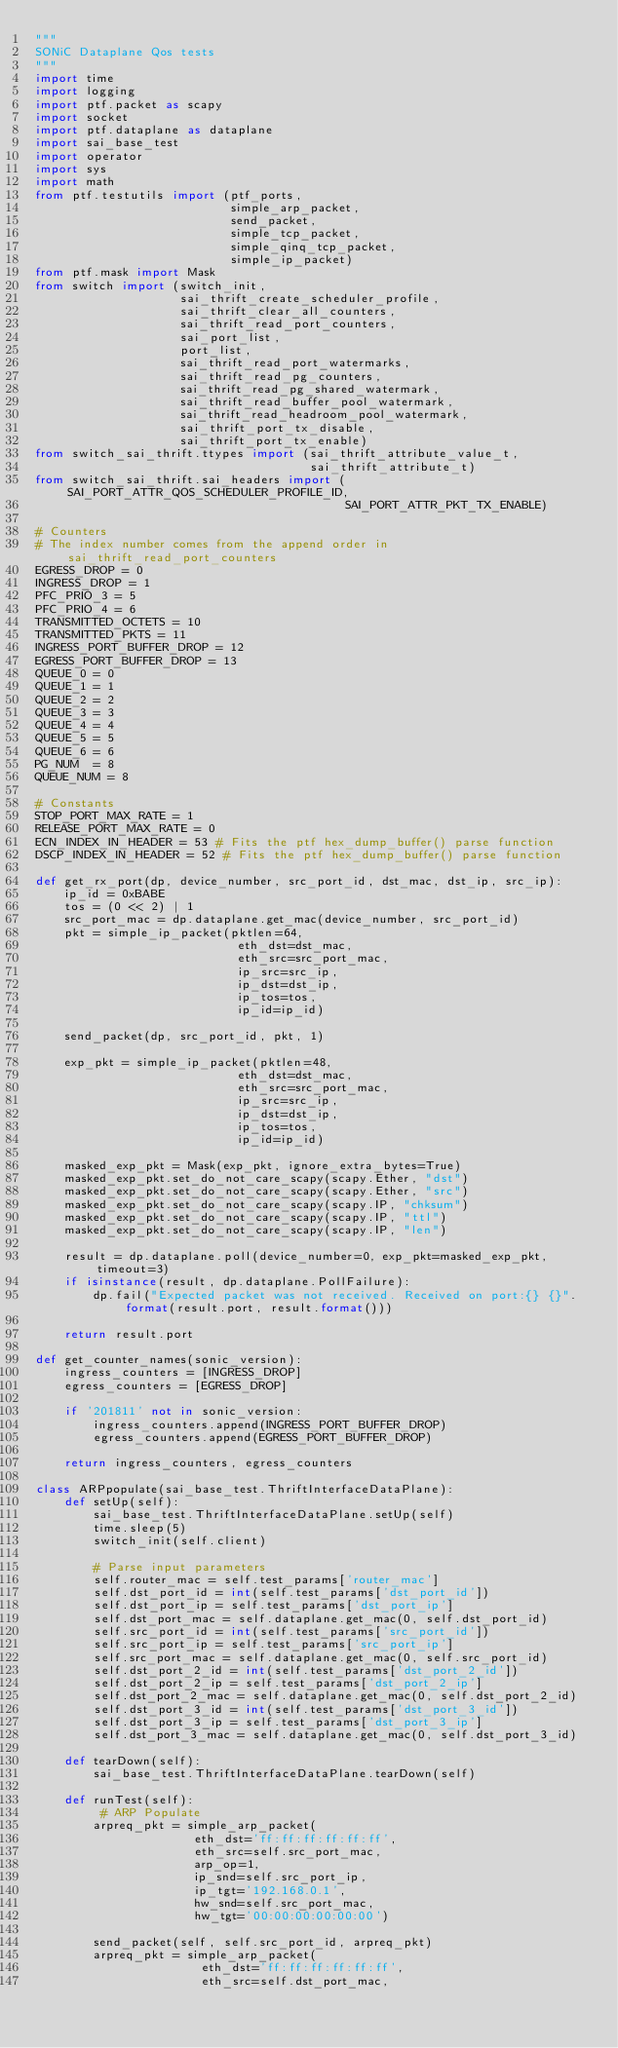Convert code to text. <code><loc_0><loc_0><loc_500><loc_500><_Python_>"""
SONiC Dataplane Qos tests
"""
import time
import logging
import ptf.packet as scapy
import socket
import ptf.dataplane as dataplane
import sai_base_test
import operator
import sys
import math
from ptf.testutils import (ptf_ports,
                           simple_arp_packet,
                           send_packet,
                           simple_tcp_packet,
                           simple_qinq_tcp_packet,
                           simple_ip_packet)
from ptf.mask import Mask
from switch import (switch_init,
                    sai_thrift_create_scheduler_profile,
                    sai_thrift_clear_all_counters,
                    sai_thrift_read_port_counters,
                    sai_port_list,
                    port_list,
                    sai_thrift_read_port_watermarks,
                    sai_thrift_read_pg_counters,
                    sai_thrift_read_pg_shared_watermark,
                    sai_thrift_read_buffer_pool_watermark,
                    sai_thrift_read_headroom_pool_watermark,
                    sai_thrift_port_tx_disable,
                    sai_thrift_port_tx_enable)
from switch_sai_thrift.ttypes import (sai_thrift_attribute_value_t,
                                      sai_thrift_attribute_t)
from switch_sai_thrift.sai_headers import (SAI_PORT_ATTR_QOS_SCHEDULER_PROFILE_ID,
                                           SAI_PORT_ATTR_PKT_TX_ENABLE)

# Counters
# The index number comes from the append order in sai_thrift_read_port_counters
EGRESS_DROP = 0
INGRESS_DROP = 1
PFC_PRIO_3 = 5
PFC_PRIO_4 = 6
TRANSMITTED_OCTETS = 10
TRANSMITTED_PKTS = 11
INGRESS_PORT_BUFFER_DROP = 12
EGRESS_PORT_BUFFER_DROP = 13
QUEUE_0 = 0
QUEUE_1 = 1
QUEUE_2 = 2
QUEUE_3 = 3
QUEUE_4 = 4
QUEUE_5 = 5
QUEUE_6 = 6
PG_NUM  = 8
QUEUE_NUM = 8

# Constants
STOP_PORT_MAX_RATE = 1
RELEASE_PORT_MAX_RATE = 0
ECN_INDEX_IN_HEADER = 53 # Fits the ptf hex_dump_buffer() parse function
DSCP_INDEX_IN_HEADER = 52 # Fits the ptf hex_dump_buffer() parse function

def get_rx_port(dp, device_number, src_port_id, dst_mac, dst_ip, src_ip):
    ip_id = 0xBABE
    tos = (0 << 2) | 1
    src_port_mac = dp.dataplane.get_mac(device_number, src_port_id)
    pkt = simple_ip_packet(pktlen=64,
                            eth_dst=dst_mac,
                            eth_src=src_port_mac,
                            ip_src=src_ip,
                            ip_dst=dst_ip,
                            ip_tos=tos,
                            ip_id=ip_id)

    send_packet(dp, src_port_id, pkt, 1)

    exp_pkt = simple_ip_packet(pktlen=48,
                            eth_dst=dst_mac,
                            eth_src=src_port_mac,
                            ip_src=src_ip,
                            ip_dst=dst_ip,
                            ip_tos=tos,
                            ip_id=ip_id)

    masked_exp_pkt = Mask(exp_pkt, ignore_extra_bytes=True)
    masked_exp_pkt.set_do_not_care_scapy(scapy.Ether, "dst")
    masked_exp_pkt.set_do_not_care_scapy(scapy.Ether, "src")
    masked_exp_pkt.set_do_not_care_scapy(scapy.IP, "chksum")
    masked_exp_pkt.set_do_not_care_scapy(scapy.IP, "ttl")
    masked_exp_pkt.set_do_not_care_scapy(scapy.IP, "len")

    result = dp.dataplane.poll(device_number=0, exp_pkt=masked_exp_pkt, timeout=3)
    if isinstance(result, dp.dataplane.PollFailure):
        dp.fail("Expected packet was not received. Received on port:{} {}".format(result.port, result.format()))

    return result.port

def get_counter_names(sonic_version):
    ingress_counters = [INGRESS_DROP]
    egress_counters = [EGRESS_DROP]

    if '201811' not in sonic_version:
        ingress_counters.append(INGRESS_PORT_BUFFER_DROP)
        egress_counters.append(EGRESS_PORT_BUFFER_DROP)

    return ingress_counters, egress_counters

class ARPpopulate(sai_base_test.ThriftInterfaceDataPlane):
    def setUp(self):
        sai_base_test.ThriftInterfaceDataPlane.setUp(self)
        time.sleep(5)
        switch_init(self.client)

        # Parse input parameters
        self.router_mac = self.test_params['router_mac']
        self.dst_port_id = int(self.test_params['dst_port_id'])
        self.dst_port_ip = self.test_params['dst_port_ip']
        self.dst_port_mac = self.dataplane.get_mac(0, self.dst_port_id)
        self.src_port_id = int(self.test_params['src_port_id'])
        self.src_port_ip = self.test_params['src_port_ip']
        self.src_port_mac = self.dataplane.get_mac(0, self.src_port_id)
        self.dst_port_2_id = int(self.test_params['dst_port_2_id'])
        self.dst_port_2_ip = self.test_params['dst_port_2_ip']
        self.dst_port_2_mac = self.dataplane.get_mac(0, self.dst_port_2_id)
        self.dst_port_3_id = int(self.test_params['dst_port_3_id'])
        self.dst_port_3_ip = self.test_params['dst_port_3_ip']
        self.dst_port_3_mac = self.dataplane.get_mac(0, self.dst_port_3_id)

    def tearDown(self):
        sai_base_test.ThriftInterfaceDataPlane.tearDown(self)

    def runTest(self):
         # ARP Populate
        arpreq_pkt = simple_arp_packet(
                      eth_dst='ff:ff:ff:ff:ff:ff',
                      eth_src=self.src_port_mac,
                      arp_op=1,
                      ip_snd=self.src_port_ip,
                      ip_tgt='192.168.0.1',
                      hw_snd=self.src_port_mac,
                      hw_tgt='00:00:00:00:00:00')

        send_packet(self, self.src_port_id, arpreq_pkt)
        arpreq_pkt = simple_arp_packet(
                       eth_dst='ff:ff:ff:ff:ff:ff',
                       eth_src=self.dst_port_mac,</code> 